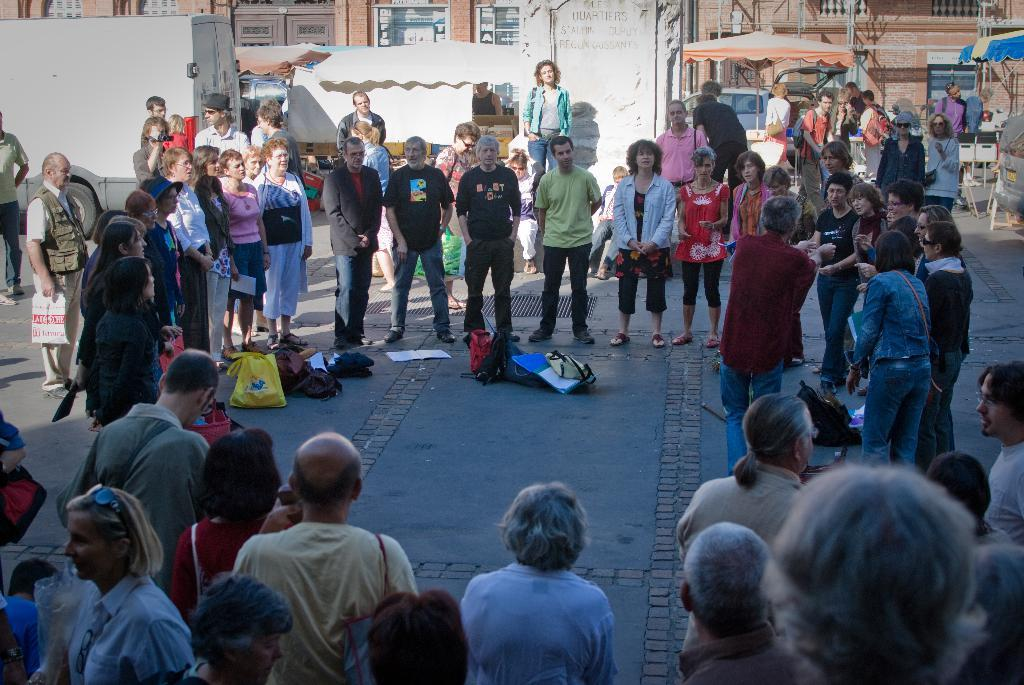What is the main subject of the image? The main subject of the image is a crowd. What can be seen on the ground in the image? There are bags and things on the ground in the image. What is visible in the background of the image? In the background, there is a memorial wall, a building, tents, and vehicles. Can you describe any architectural features in the image? There are windows visible in the image. How many pizzas are being served at the memorial wall in the image? There is no mention of pizzas in the image; the focus is on the crowd and the memorial wall. Is there any poison visible in the image? There is no indication of poison in the image; it features a crowd, a memorial wall, and various background elements. 